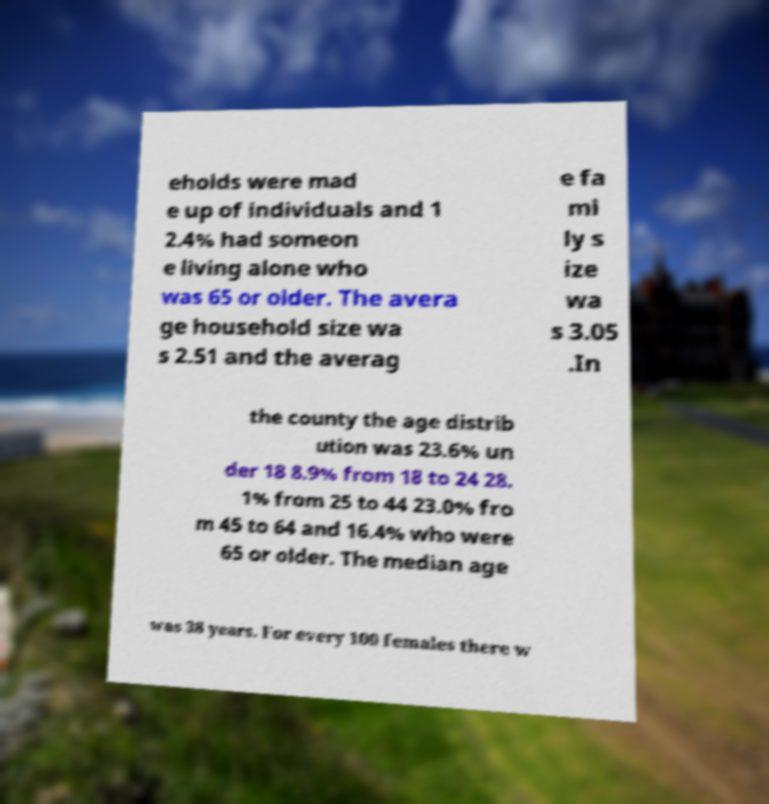Can you read and provide the text displayed in the image?This photo seems to have some interesting text. Can you extract and type it out for me? eholds were mad e up of individuals and 1 2.4% had someon e living alone who was 65 or older. The avera ge household size wa s 2.51 and the averag e fa mi ly s ize wa s 3.05 .In the county the age distrib ution was 23.6% un der 18 8.9% from 18 to 24 28. 1% from 25 to 44 23.0% fro m 45 to 64 and 16.4% who were 65 or older. The median age was 38 years. For every 100 females there w 